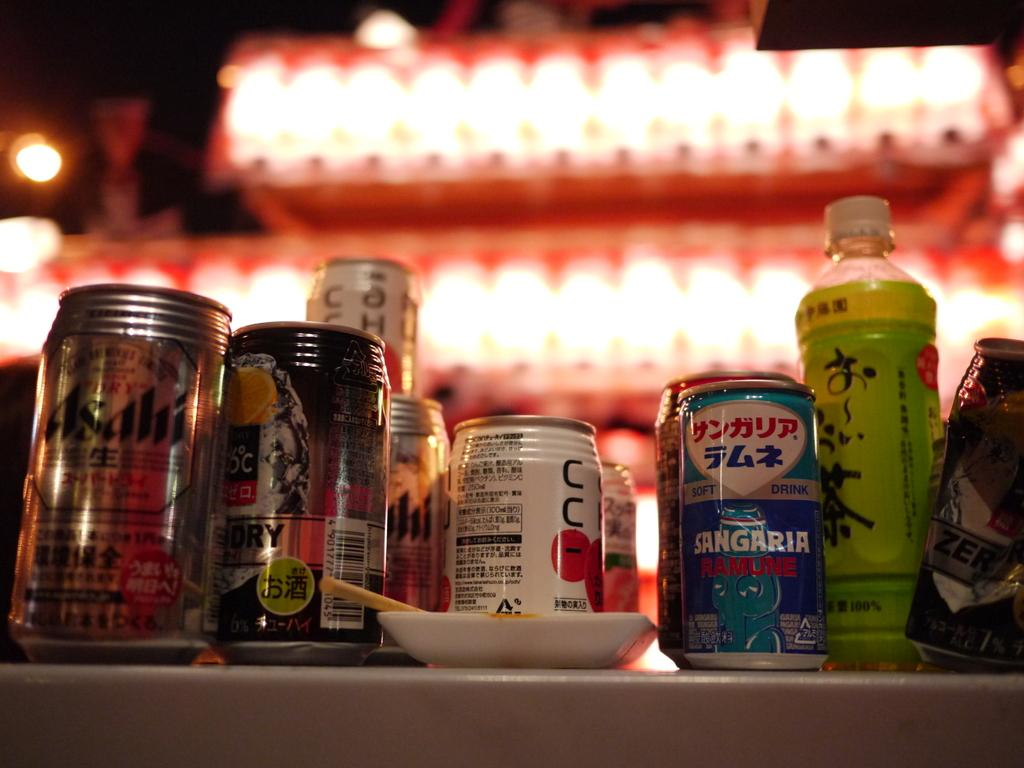<image>
Write a terse but informative summary of the picture. Various bottles of beer rest on a table including Asahi and Sangaria Ramune. 